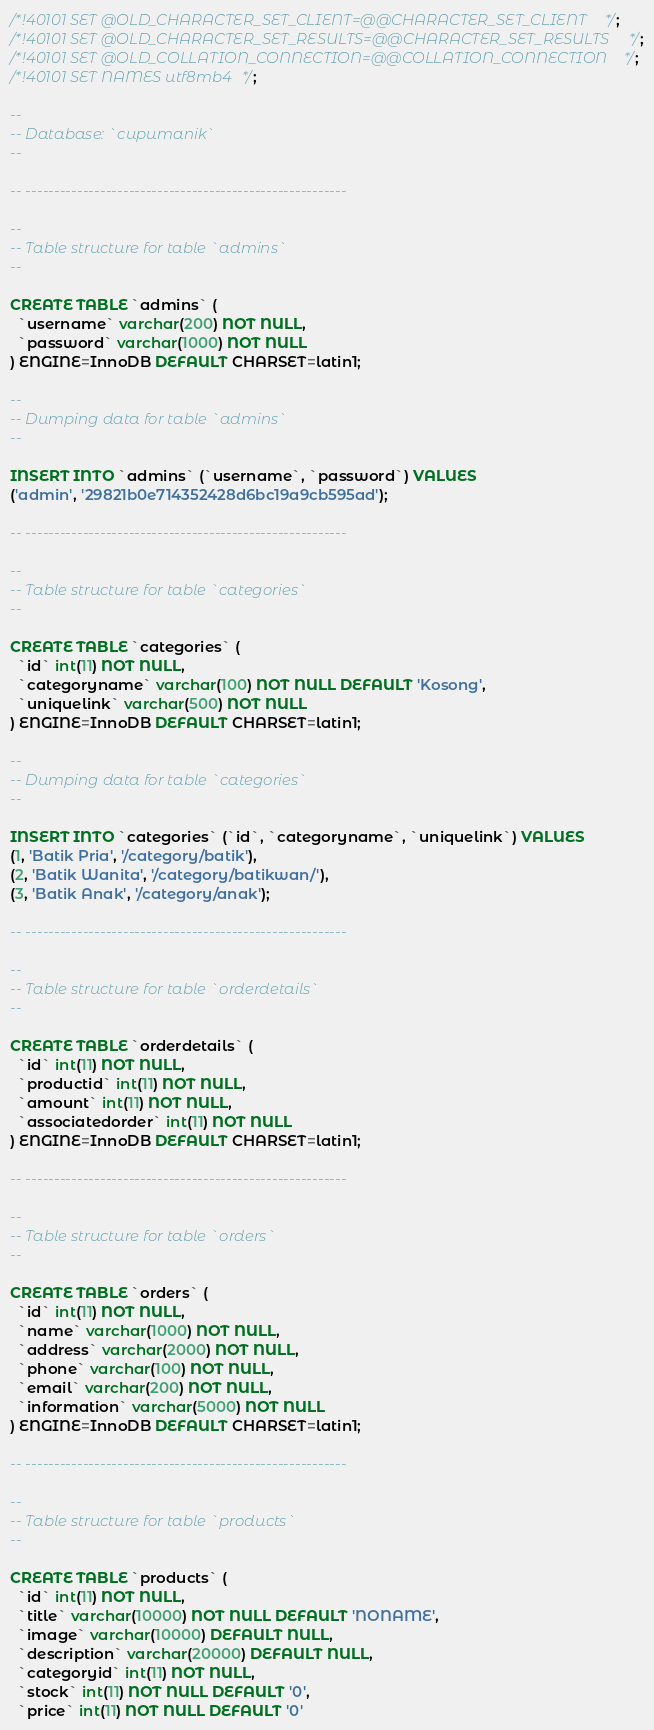Convert code to text. <code><loc_0><loc_0><loc_500><loc_500><_SQL_>
/*!40101 SET @OLD_CHARACTER_SET_CLIENT=@@CHARACTER_SET_CLIENT */;
/*!40101 SET @OLD_CHARACTER_SET_RESULTS=@@CHARACTER_SET_RESULTS */;
/*!40101 SET @OLD_COLLATION_CONNECTION=@@COLLATION_CONNECTION */;
/*!40101 SET NAMES utf8mb4 */;

--
-- Database: `cupumanik`
--

-- --------------------------------------------------------

--
-- Table structure for table `admins`
--

CREATE TABLE `admins` (
  `username` varchar(200) NOT NULL,
  `password` varchar(1000) NOT NULL
) ENGINE=InnoDB DEFAULT CHARSET=latin1;

--
-- Dumping data for table `admins`
--

INSERT INTO `admins` (`username`, `password`) VALUES
('admin', '29821b0e714352428d6bc19a9cb595ad');

-- --------------------------------------------------------

--
-- Table structure for table `categories`
--

CREATE TABLE `categories` (
  `id` int(11) NOT NULL,
  `categoryname` varchar(100) NOT NULL DEFAULT 'Kosong',
  `uniquelink` varchar(500) NOT NULL
) ENGINE=InnoDB DEFAULT CHARSET=latin1;

--
-- Dumping data for table `categories`
--

INSERT INTO `categories` (`id`, `categoryname`, `uniquelink`) VALUES
(1, 'Batik Pria', '/category/batik'),
(2, 'Batik Wanita', '/category/batikwan/'),
(3, 'Batik Anak', '/category/anak');

-- --------------------------------------------------------

--
-- Table structure for table `orderdetails`
--

CREATE TABLE `orderdetails` (
  `id` int(11) NOT NULL,
  `productid` int(11) NOT NULL,
  `amount` int(11) NOT NULL,
  `associatedorder` int(11) NOT NULL
) ENGINE=InnoDB DEFAULT CHARSET=latin1;

-- --------------------------------------------------------

--
-- Table structure for table `orders`
--

CREATE TABLE `orders` (
  `id` int(11) NOT NULL,
  `name` varchar(1000) NOT NULL,
  `address` varchar(2000) NOT NULL,
  `phone` varchar(100) NOT NULL,
  `email` varchar(200) NOT NULL,
  `information` varchar(5000) NOT NULL
) ENGINE=InnoDB DEFAULT CHARSET=latin1;

-- --------------------------------------------------------

--
-- Table structure for table `products`
--

CREATE TABLE `products` (
  `id` int(11) NOT NULL,
  `title` varchar(10000) NOT NULL DEFAULT 'NONAME',
  `image` varchar(10000) DEFAULT NULL,
  `description` varchar(20000) DEFAULT NULL,
  `categoryid` int(11) NOT NULL,
  `stock` int(11) NOT NULL DEFAULT '0',
  `price` int(11) NOT NULL DEFAULT '0'</code> 